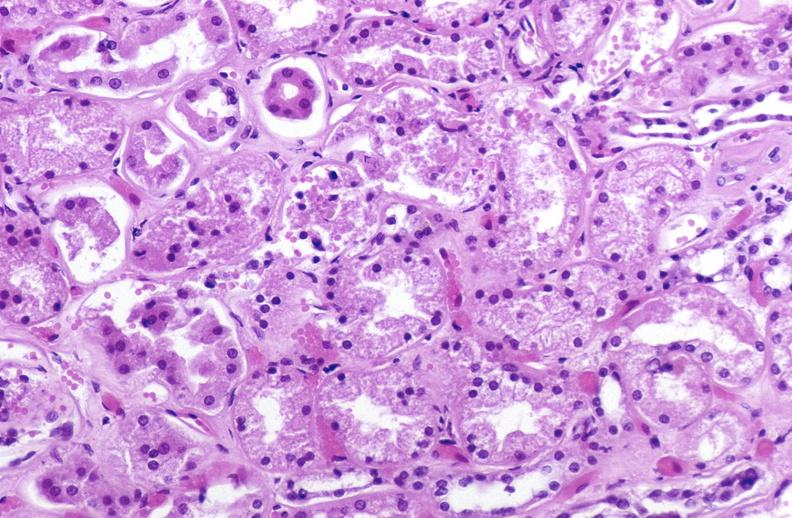what is present?
Answer the question using a single word or phrase. Urinary 